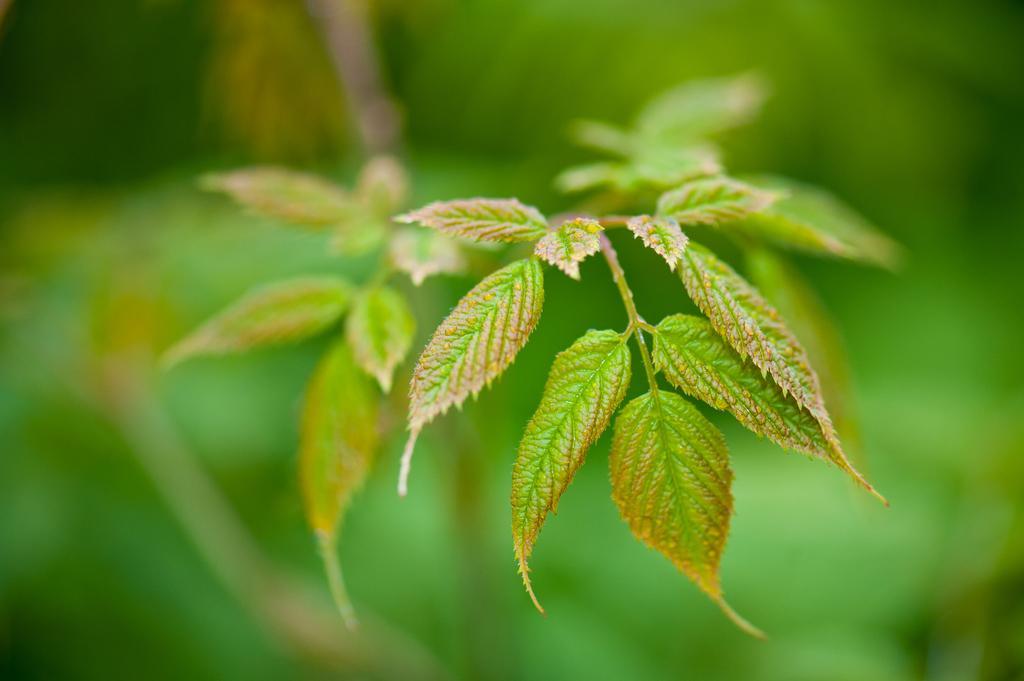Describe this image in one or two sentences. This is the picture of a plant. In this image there is a green color leaves on the plant. At the back the image is blurry. 